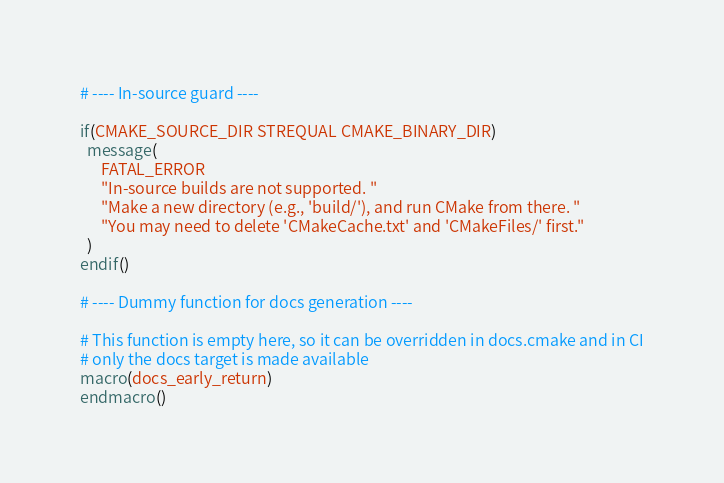<code> <loc_0><loc_0><loc_500><loc_500><_CMake_># ---- In-source guard ----

if(CMAKE_SOURCE_DIR STREQUAL CMAKE_BINARY_DIR)
  message(
      FATAL_ERROR
      "In-source builds are not supported. "
      "Make a new directory (e.g., 'build/'), and run CMake from there. "
      "You may need to delete 'CMakeCache.txt' and 'CMakeFiles/' first."
  )
endif()

# ---- Dummy function for docs generation ----

# This function is empty here, so it can be overridden in docs.cmake and in CI
# only the docs target is made available
macro(docs_early_return)
endmacro()
</code> 